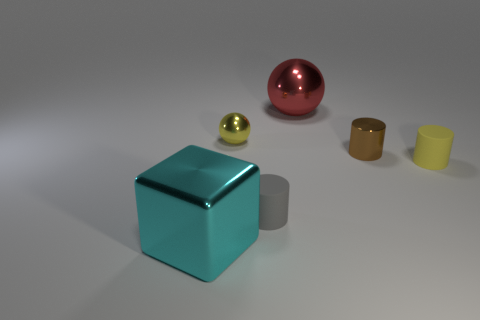Subtract all brown metallic cylinders. How many cylinders are left? 2 Add 3 small brown cylinders. How many objects exist? 9 Subtract 1 cylinders. How many cylinders are left? 2 Subtract all balls. How many objects are left? 4 Subtract all purple cylinders. Subtract all cyan cubes. How many cylinders are left? 3 Subtract 1 cyan cubes. How many objects are left? 5 Subtract all small yellow cylinders. Subtract all tiny yellow spheres. How many objects are left? 4 Add 2 tiny things. How many tiny things are left? 6 Add 5 large green matte cubes. How many large green matte cubes exist? 5 